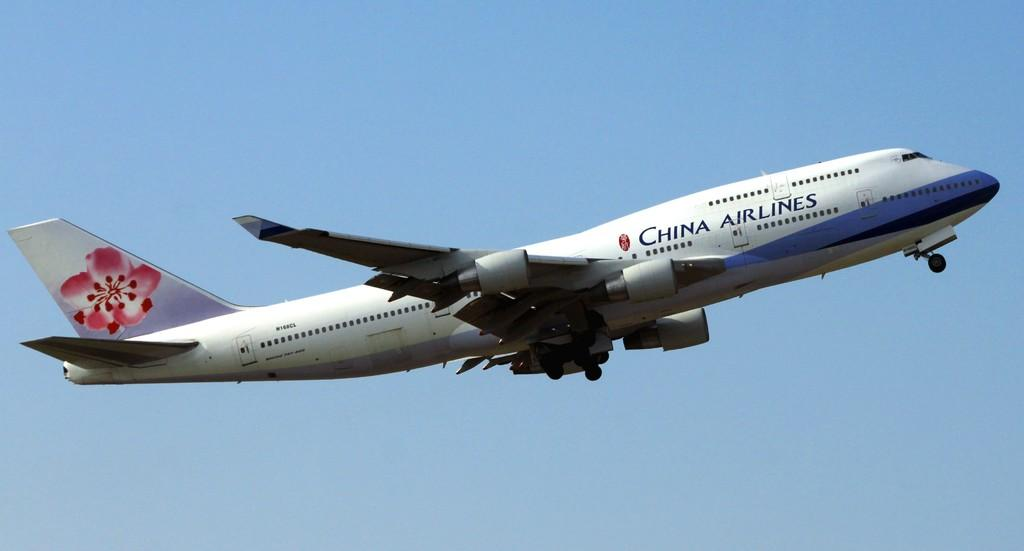<image>
Share a concise interpretation of the image provided. a China airlines jet in a very clear blue sky. 